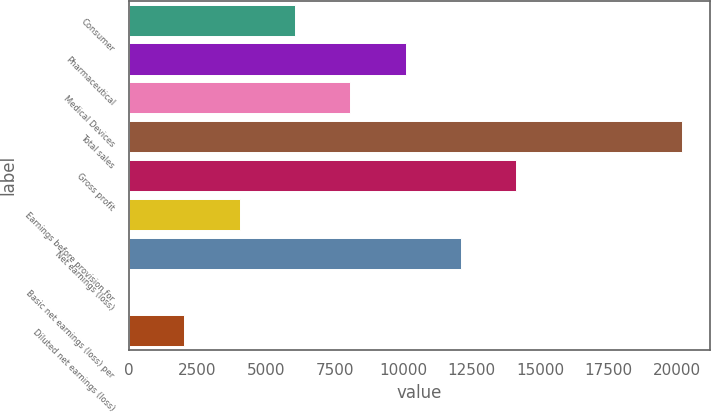Convert chart. <chart><loc_0><loc_0><loc_500><loc_500><bar_chart><fcel>Consumer<fcel>Pharmaceutical<fcel>Medical Devices<fcel>Total sales<fcel>Gross profit<fcel>Earnings before provision for<fcel>Net earnings (loss)<fcel>Basic net earnings (loss) per<fcel>Diluted net earnings (loss)<nl><fcel>6061.29<fcel>10099.5<fcel>8080.39<fcel>20195<fcel>14137.7<fcel>4042.19<fcel>12118.6<fcel>3.99<fcel>2023.09<nl></chart> 